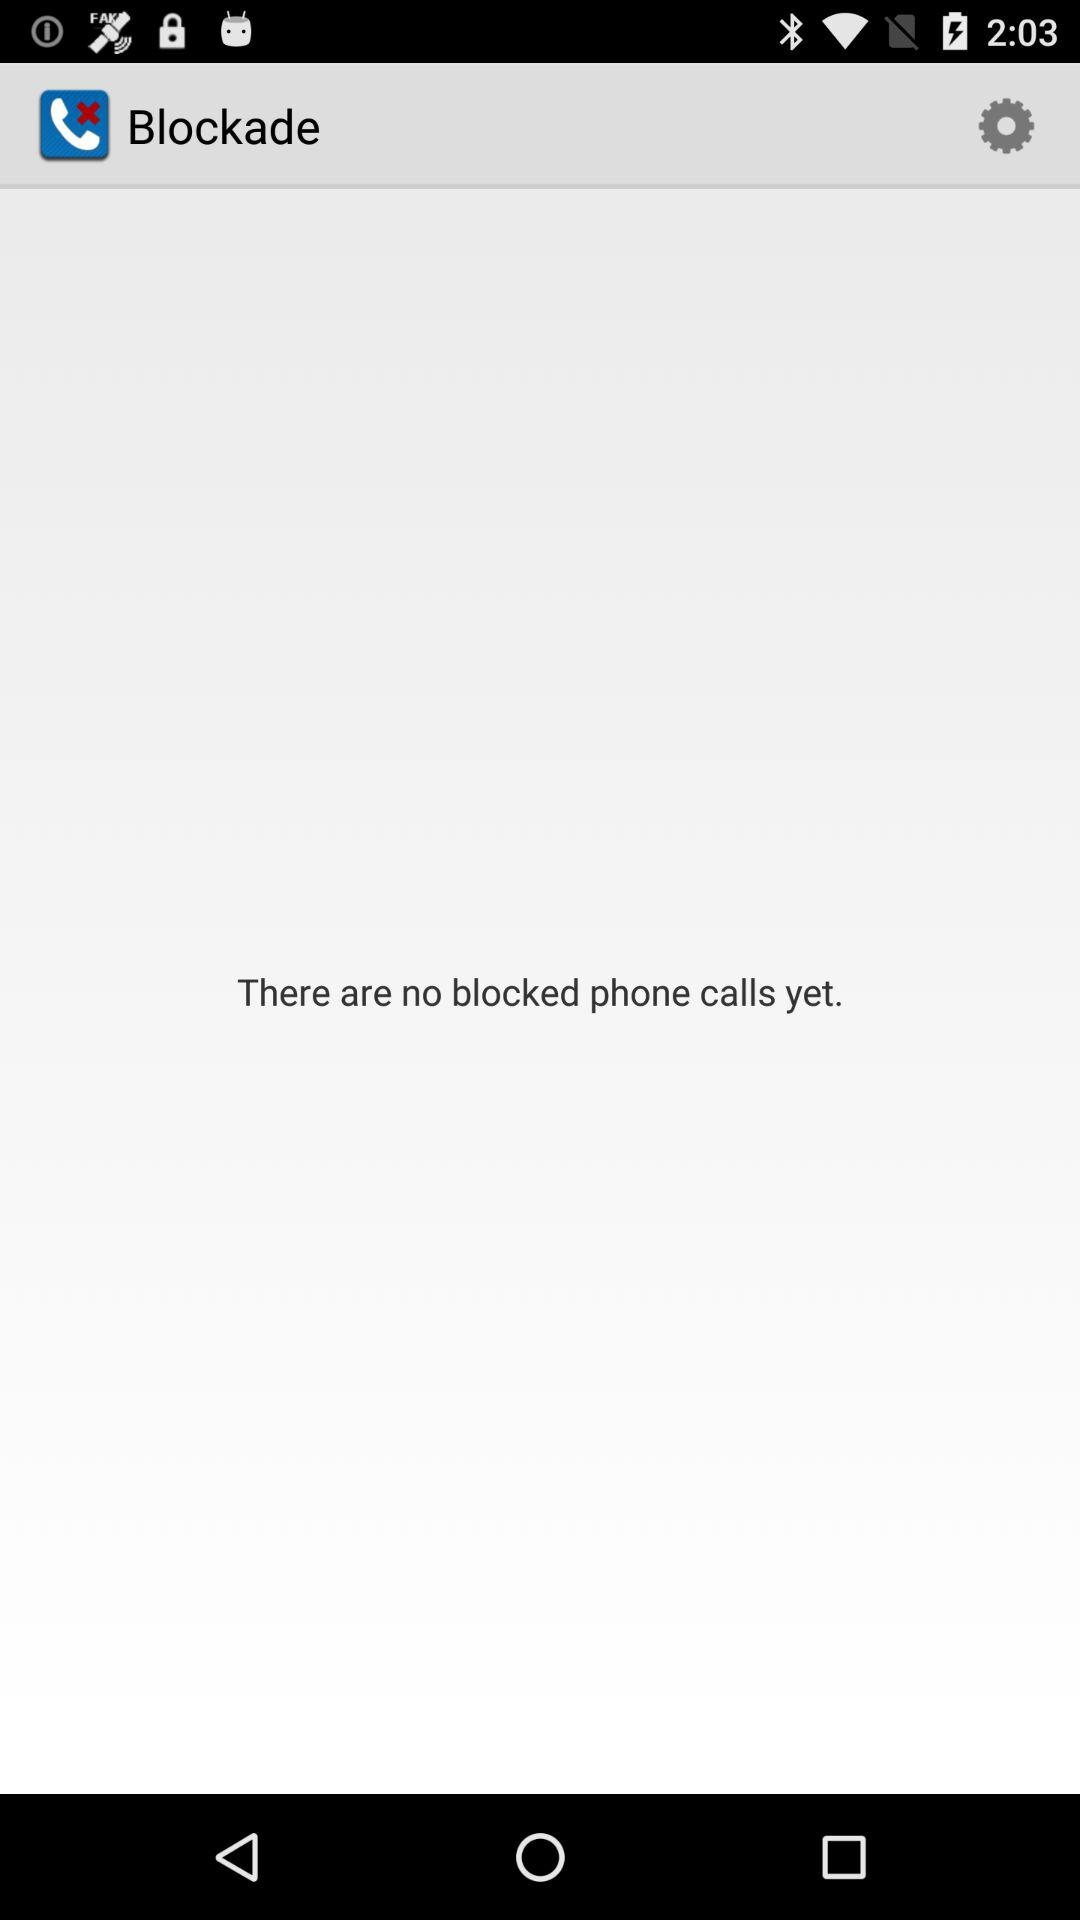How many phone calls are blocked?
Answer the question using a single word or phrase. 0 